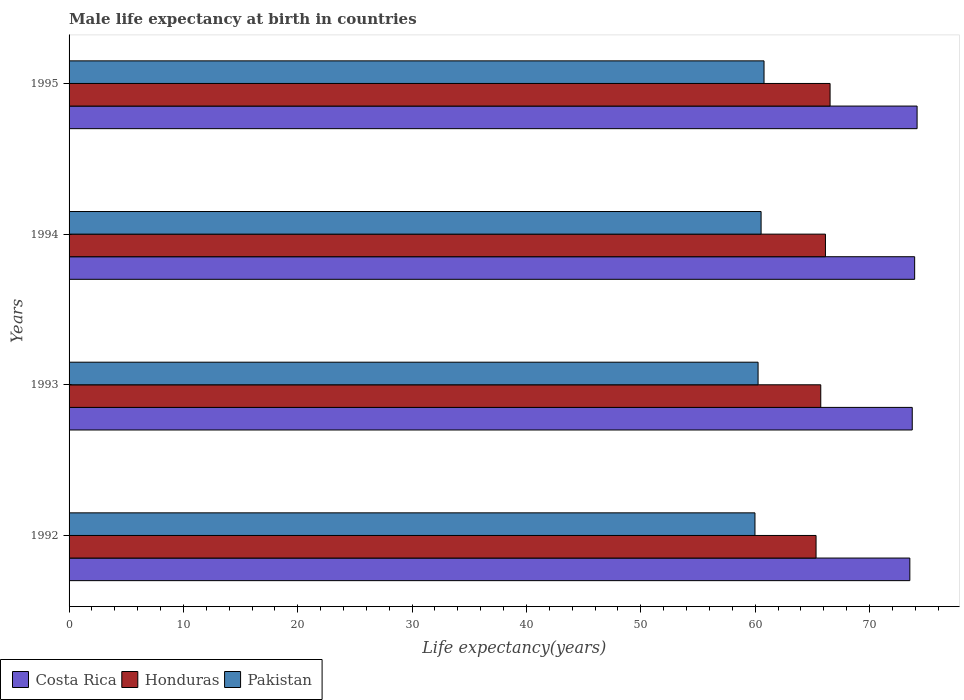Are the number of bars per tick equal to the number of legend labels?
Keep it short and to the point. Yes. How many bars are there on the 1st tick from the top?
Give a very brief answer. 3. How many bars are there on the 1st tick from the bottom?
Keep it short and to the point. 3. What is the male life expectancy at birth in Costa Rica in 1993?
Offer a very short reply. 73.74. Across all years, what is the maximum male life expectancy at birth in Costa Rica?
Make the answer very short. 74.16. Across all years, what is the minimum male life expectancy at birth in Honduras?
Ensure brevity in your answer.  65.33. In which year was the male life expectancy at birth in Honduras minimum?
Offer a very short reply. 1992. What is the total male life expectancy at birth in Costa Rica in the graph?
Provide a succinct answer. 295.38. What is the difference between the male life expectancy at birth in Costa Rica in 1993 and that in 1994?
Provide a short and direct response. -0.21. What is the difference between the male life expectancy at birth in Honduras in 1993 and the male life expectancy at birth in Costa Rica in 1992?
Give a very brief answer. -7.79. What is the average male life expectancy at birth in Honduras per year?
Offer a terse response. 65.94. In the year 1993, what is the difference between the male life expectancy at birth in Costa Rica and male life expectancy at birth in Pakistan?
Your answer should be very brief. 13.48. What is the ratio of the male life expectancy at birth in Pakistan in 1994 to that in 1995?
Your answer should be compact. 1. Is the male life expectancy at birth in Pakistan in 1992 less than that in 1993?
Keep it short and to the point. Yes. Is the difference between the male life expectancy at birth in Costa Rica in 1992 and 1994 greater than the difference between the male life expectancy at birth in Pakistan in 1992 and 1994?
Offer a terse response. Yes. What is the difference between the highest and the second highest male life expectancy at birth in Honduras?
Provide a short and direct response. 0.41. What is the difference between the highest and the lowest male life expectancy at birth in Honduras?
Offer a very short reply. 1.23. In how many years, is the male life expectancy at birth in Costa Rica greater than the average male life expectancy at birth in Costa Rica taken over all years?
Your response must be concise. 2. What does the 1st bar from the top in 1995 represents?
Ensure brevity in your answer.  Pakistan. What does the 3rd bar from the bottom in 1992 represents?
Ensure brevity in your answer.  Pakistan. How many bars are there?
Offer a terse response. 12. Are all the bars in the graph horizontal?
Give a very brief answer. Yes. How many years are there in the graph?
Give a very brief answer. 4. Does the graph contain any zero values?
Make the answer very short. No. How many legend labels are there?
Provide a succinct answer. 3. How are the legend labels stacked?
Your answer should be very brief. Horizontal. What is the title of the graph?
Keep it short and to the point. Male life expectancy at birth in countries. What is the label or title of the X-axis?
Make the answer very short. Life expectancy(years). What is the Life expectancy(years) in Costa Rica in 1992?
Give a very brief answer. 73.53. What is the Life expectancy(years) in Honduras in 1992?
Your answer should be compact. 65.33. What is the Life expectancy(years) of Pakistan in 1992?
Keep it short and to the point. 59.98. What is the Life expectancy(years) of Costa Rica in 1993?
Ensure brevity in your answer.  73.74. What is the Life expectancy(years) of Honduras in 1993?
Provide a succinct answer. 65.74. What is the Life expectancy(years) of Pakistan in 1993?
Provide a succinct answer. 60.26. What is the Life expectancy(years) of Costa Rica in 1994?
Give a very brief answer. 73.95. What is the Life expectancy(years) of Honduras in 1994?
Give a very brief answer. 66.15. What is the Life expectancy(years) in Pakistan in 1994?
Give a very brief answer. 60.52. What is the Life expectancy(years) in Costa Rica in 1995?
Offer a terse response. 74.16. What is the Life expectancy(years) of Honduras in 1995?
Your answer should be very brief. 66.55. What is the Life expectancy(years) in Pakistan in 1995?
Provide a succinct answer. 60.78. Across all years, what is the maximum Life expectancy(years) in Costa Rica?
Your answer should be very brief. 74.16. Across all years, what is the maximum Life expectancy(years) in Honduras?
Ensure brevity in your answer.  66.55. Across all years, what is the maximum Life expectancy(years) of Pakistan?
Offer a terse response. 60.78. Across all years, what is the minimum Life expectancy(years) in Costa Rica?
Provide a short and direct response. 73.53. Across all years, what is the minimum Life expectancy(years) of Honduras?
Your answer should be compact. 65.33. Across all years, what is the minimum Life expectancy(years) in Pakistan?
Your response must be concise. 59.98. What is the total Life expectancy(years) in Costa Rica in the graph?
Provide a succinct answer. 295.38. What is the total Life expectancy(years) in Honduras in the graph?
Your answer should be very brief. 263.77. What is the total Life expectancy(years) of Pakistan in the graph?
Make the answer very short. 241.54. What is the difference between the Life expectancy(years) of Costa Rica in 1992 and that in 1993?
Give a very brief answer. -0.21. What is the difference between the Life expectancy(years) in Honduras in 1992 and that in 1993?
Your answer should be very brief. -0.41. What is the difference between the Life expectancy(years) in Pakistan in 1992 and that in 1993?
Provide a short and direct response. -0.27. What is the difference between the Life expectancy(years) of Costa Rica in 1992 and that in 1994?
Provide a succinct answer. -0.42. What is the difference between the Life expectancy(years) in Honduras in 1992 and that in 1994?
Your answer should be compact. -0.82. What is the difference between the Life expectancy(years) of Pakistan in 1992 and that in 1994?
Provide a succinct answer. -0.54. What is the difference between the Life expectancy(years) of Costa Rica in 1992 and that in 1995?
Your answer should be very brief. -0.63. What is the difference between the Life expectancy(years) in Honduras in 1992 and that in 1995?
Offer a very short reply. -1.23. What is the difference between the Life expectancy(years) in Pakistan in 1992 and that in 1995?
Ensure brevity in your answer.  -0.79. What is the difference between the Life expectancy(years) of Costa Rica in 1993 and that in 1994?
Offer a very short reply. -0.21. What is the difference between the Life expectancy(years) of Honduras in 1993 and that in 1994?
Make the answer very short. -0.41. What is the difference between the Life expectancy(years) in Pakistan in 1993 and that in 1994?
Provide a succinct answer. -0.26. What is the difference between the Life expectancy(years) in Costa Rica in 1993 and that in 1995?
Provide a short and direct response. -0.42. What is the difference between the Life expectancy(years) in Honduras in 1993 and that in 1995?
Provide a succinct answer. -0.81. What is the difference between the Life expectancy(years) in Pakistan in 1993 and that in 1995?
Give a very brief answer. -0.52. What is the difference between the Life expectancy(years) of Costa Rica in 1994 and that in 1995?
Make the answer very short. -0.21. What is the difference between the Life expectancy(years) in Honduras in 1994 and that in 1995?
Ensure brevity in your answer.  -0.41. What is the difference between the Life expectancy(years) of Pakistan in 1994 and that in 1995?
Keep it short and to the point. -0.26. What is the difference between the Life expectancy(years) of Costa Rica in 1992 and the Life expectancy(years) of Honduras in 1993?
Give a very brief answer. 7.79. What is the difference between the Life expectancy(years) of Costa Rica in 1992 and the Life expectancy(years) of Pakistan in 1993?
Offer a very short reply. 13.27. What is the difference between the Life expectancy(years) of Honduras in 1992 and the Life expectancy(years) of Pakistan in 1993?
Offer a very short reply. 5.07. What is the difference between the Life expectancy(years) of Costa Rica in 1992 and the Life expectancy(years) of Honduras in 1994?
Your response must be concise. 7.38. What is the difference between the Life expectancy(years) of Costa Rica in 1992 and the Life expectancy(years) of Pakistan in 1994?
Give a very brief answer. 13.01. What is the difference between the Life expectancy(years) of Honduras in 1992 and the Life expectancy(years) of Pakistan in 1994?
Your answer should be very brief. 4.81. What is the difference between the Life expectancy(years) in Costa Rica in 1992 and the Life expectancy(years) in Honduras in 1995?
Give a very brief answer. 6.97. What is the difference between the Life expectancy(years) in Costa Rica in 1992 and the Life expectancy(years) in Pakistan in 1995?
Your answer should be very brief. 12.75. What is the difference between the Life expectancy(years) in Honduras in 1992 and the Life expectancy(years) in Pakistan in 1995?
Ensure brevity in your answer.  4.55. What is the difference between the Life expectancy(years) in Costa Rica in 1993 and the Life expectancy(years) in Honduras in 1994?
Keep it short and to the point. 7.59. What is the difference between the Life expectancy(years) of Costa Rica in 1993 and the Life expectancy(years) of Pakistan in 1994?
Your answer should be very brief. 13.22. What is the difference between the Life expectancy(years) in Honduras in 1993 and the Life expectancy(years) in Pakistan in 1994?
Keep it short and to the point. 5.22. What is the difference between the Life expectancy(years) of Costa Rica in 1993 and the Life expectancy(years) of Honduras in 1995?
Make the answer very short. 7.18. What is the difference between the Life expectancy(years) of Costa Rica in 1993 and the Life expectancy(years) of Pakistan in 1995?
Your answer should be compact. 12.96. What is the difference between the Life expectancy(years) in Honduras in 1993 and the Life expectancy(years) in Pakistan in 1995?
Offer a very short reply. 4.96. What is the difference between the Life expectancy(years) of Costa Rica in 1994 and the Life expectancy(years) of Honduras in 1995?
Provide a short and direct response. 7.4. What is the difference between the Life expectancy(years) of Costa Rica in 1994 and the Life expectancy(years) of Pakistan in 1995?
Give a very brief answer. 13.17. What is the difference between the Life expectancy(years) in Honduras in 1994 and the Life expectancy(years) in Pakistan in 1995?
Your answer should be compact. 5.37. What is the average Life expectancy(years) of Costa Rica per year?
Make the answer very short. 73.85. What is the average Life expectancy(years) in Honduras per year?
Your answer should be compact. 65.94. What is the average Life expectancy(years) of Pakistan per year?
Provide a succinct answer. 60.38. In the year 1992, what is the difference between the Life expectancy(years) of Costa Rica and Life expectancy(years) of Honduras?
Ensure brevity in your answer.  8.2. In the year 1992, what is the difference between the Life expectancy(years) of Costa Rica and Life expectancy(years) of Pakistan?
Your answer should be compact. 13.54. In the year 1992, what is the difference between the Life expectancy(years) in Honduras and Life expectancy(years) in Pakistan?
Offer a very short reply. 5.34. In the year 1993, what is the difference between the Life expectancy(years) of Costa Rica and Life expectancy(years) of Pakistan?
Provide a short and direct response. 13.48. In the year 1993, what is the difference between the Life expectancy(years) of Honduras and Life expectancy(years) of Pakistan?
Ensure brevity in your answer.  5.48. In the year 1994, what is the difference between the Life expectancy(years) in Costa Rica and Life expectancy(years) in Honduras?
Make the answer very short. 7.8. In the year 1994, what is the difference between the Life expectancy(years) of Costa Rica and Life expectancy(years) of Pakistan?
Offer a very short reply. 13.43. In the year 1994, what is the difference between the Life expectancy(years) of Honduras and Life expectancy(years) of Pakistan?
Your response must be concise. 5.63. In the year 1995, what is the difference between the Life expectancy(years) in Costa Rica and Life expectancy(years) in Honduras?
Make the answer very short. 7.61. In the year 1995, what is the difference between the Life expectancy(years) in Costa Rica and Life expectancy(years) in Pakistan?
Your response must be concise. 13.39. In the year 1995, what is the difference between the Life expectancy(years) of Honduras and Life expectancy(years) of Pakistan?
Offer a terse response. 5.78. What is the ratio of the Life expectancy(years) of Honduras in 1992 to that in 1993?
Your answer should be very brief. 0.99. What is the ratio of the Life expectancy(years) of Pakistan in 1992 to that in 1993?
Your answer should be compact. 1. What is the ratio of the Life expectancy(years) in Costa Rica in 1992 to that in 1994?
Give a very brief answer. 0.99. What is the ratio of the Life expectancy(years) in Honduras in 1992 to that in 1994?
Make the answer very short. 0.99. What is the ratio of the Life expectancy(years) in Pakistan in 1992 to that in 1994?
Keep it short and to the point. 0.99. What is the ratio of the Life expectancy(years) of Honduras in 1992 to that in 1995?
Provide a short and direct response. 0.98. What is the ratio of the Life expectancy(years) in Costa Rica in 1993 to that in 1994?
Ensure brevity in your answer.  1. What is the ratio of the Life expectancy(years) of Pakistan in 1993 to that in 1994?
Your answer should be compact. 1. What is the ratio of the Life expectancy(years) in Honduras in 1993 to that in 1995?
Your answer should be compact. 0.99. What is the ratio of the Life expectancy(years) in Pakistan in 1993 to that in 1995?
Your response must be concise. 0.99. What is the ratio of the Life expectancy(years) of Honduras in 1994 to that in 1995?
Give a very brief answer. 0.99. What is the ratio of the Life expectancy(years) of Pakistan in 1994 to that in 1995?
Keep it short and to the point. 1. What is the difference between the highest and the second highest Life expectancy(years) of Costa Rica?
Keep it short and to the point. 0.21. What is the difference between the highest and the second highest Life expectancy(years) in Honduras?
Offer a terse response. 0.41. What is the difference between the highest and the second highest Life expectancy(years) of Pakistan?
Your response must be concise. 0.26. What is the difference between the highest and the lowest Life expectancy(years) of Costa Rica?
Make the answer very short. 0.63. What is the difference between the highest and the lowest Life expectancy(years) of Honduras?
Make the answer very short. 1.23. What is the difference between the highest and the lowest Life expectancy(years) of Pakistan?
Offer a very short reply. 0.79. 